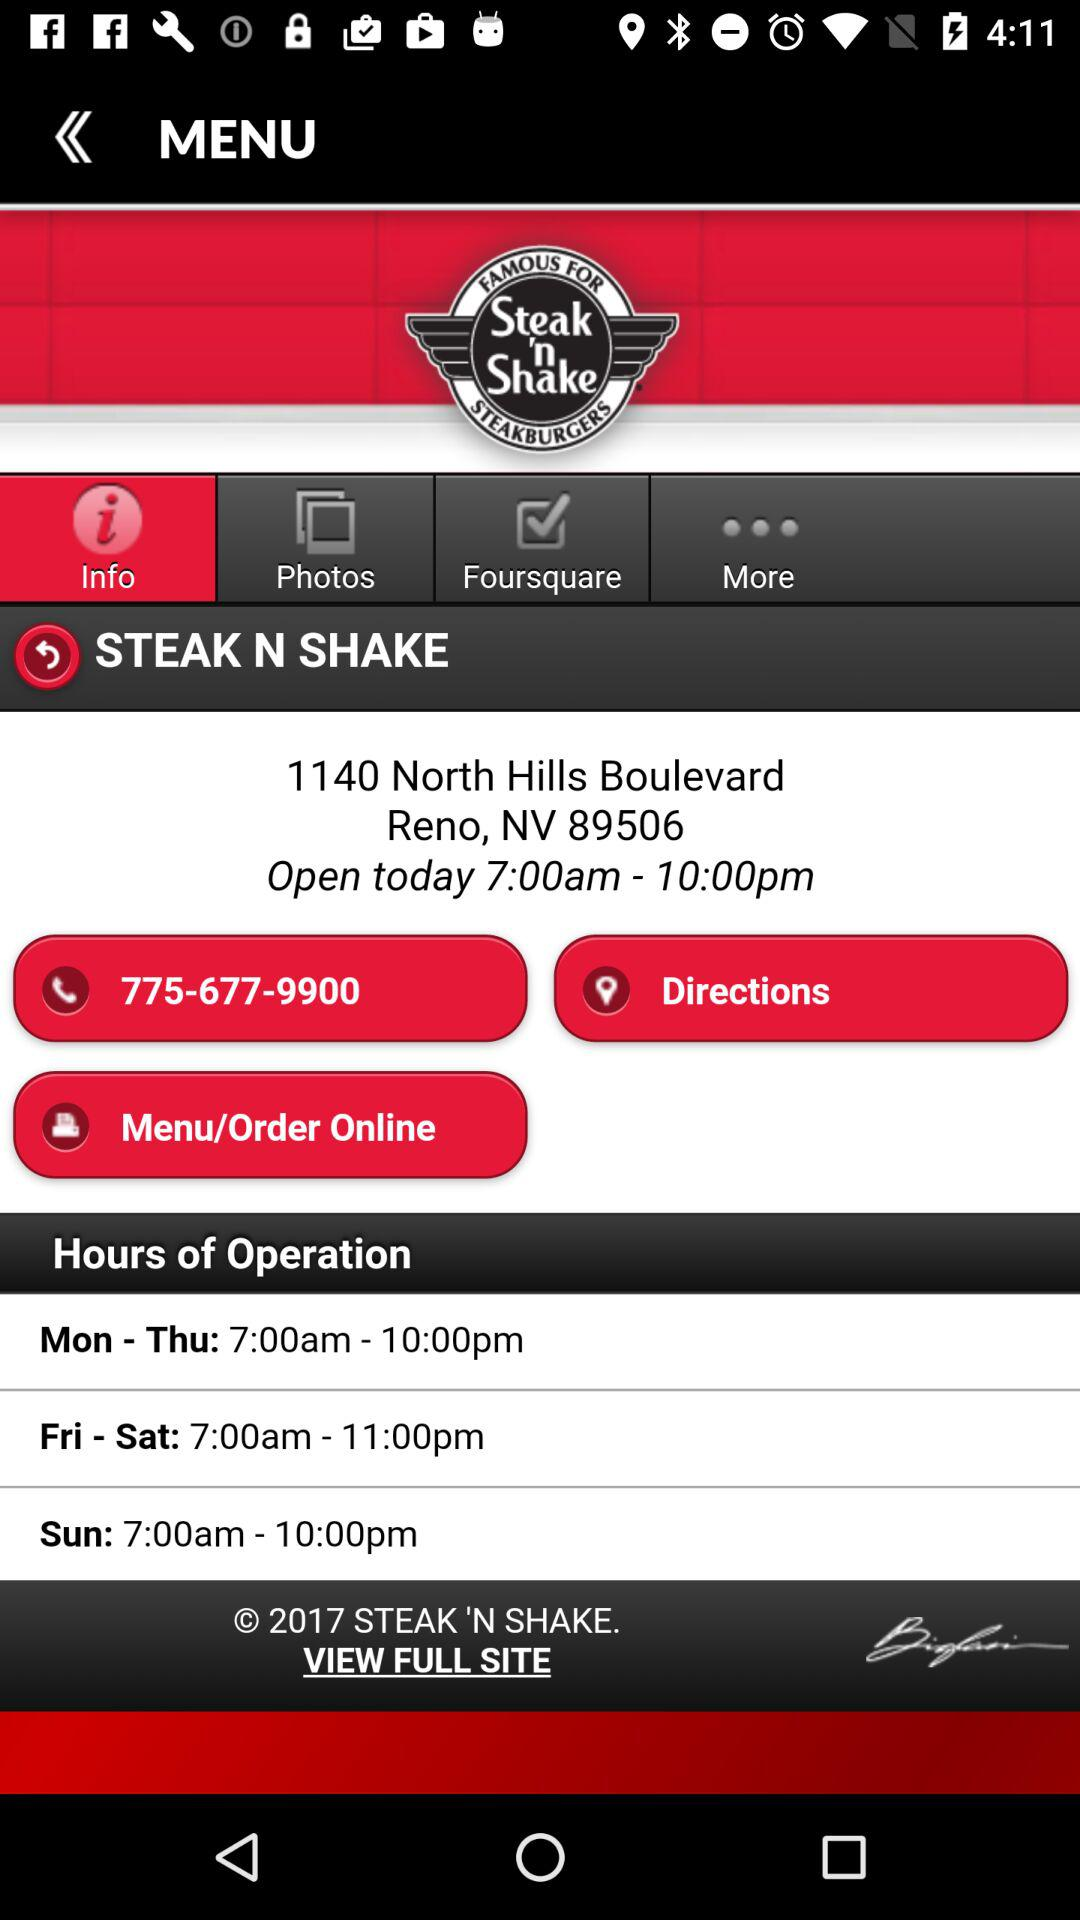On which day is the store open from 7:00 a.m. to 11:00 p.m.? The store is open from 7:00 a.m. to 11:00 p.m. on Friday and Saturday. 